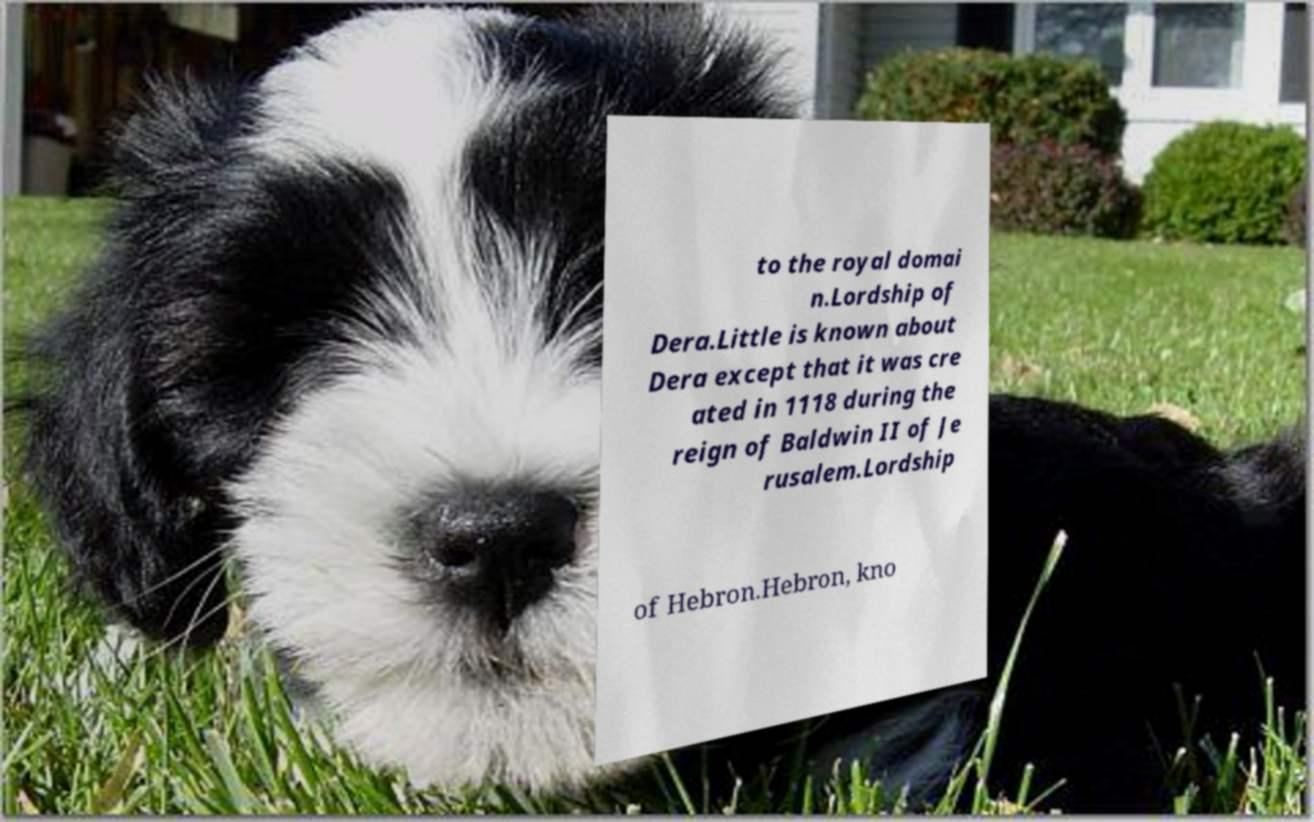Please read and relay the text visible in this image. What does it say? to the royal domai n.Lordship of Dera.Little is known about Dera except that it was cre ated in 1118 during the reign of Baldwin II of Je rusalem.Lordship of Hebron.Hebron, kno 